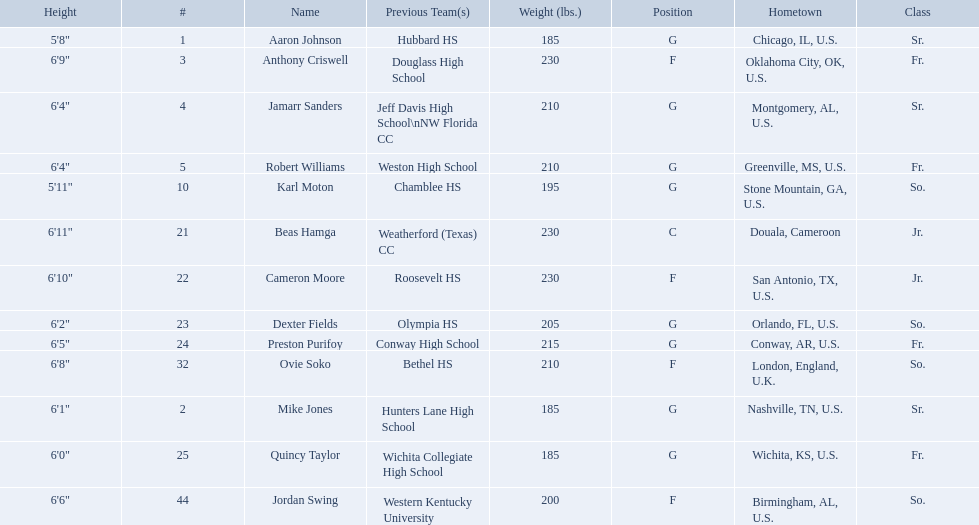Other than soko, who are the players? Aaron Johnson, Anthony Criswell, Jamarr Sanders, Robert Williams, Karl Moton, Beas Hamga, Cameron Moore, Dexter Fields, Preston Purifoy, Mike Jones, Quincy Taylor, Jordan Swing. Of those players, who is a player that is not from the us? Beas Hamga. 